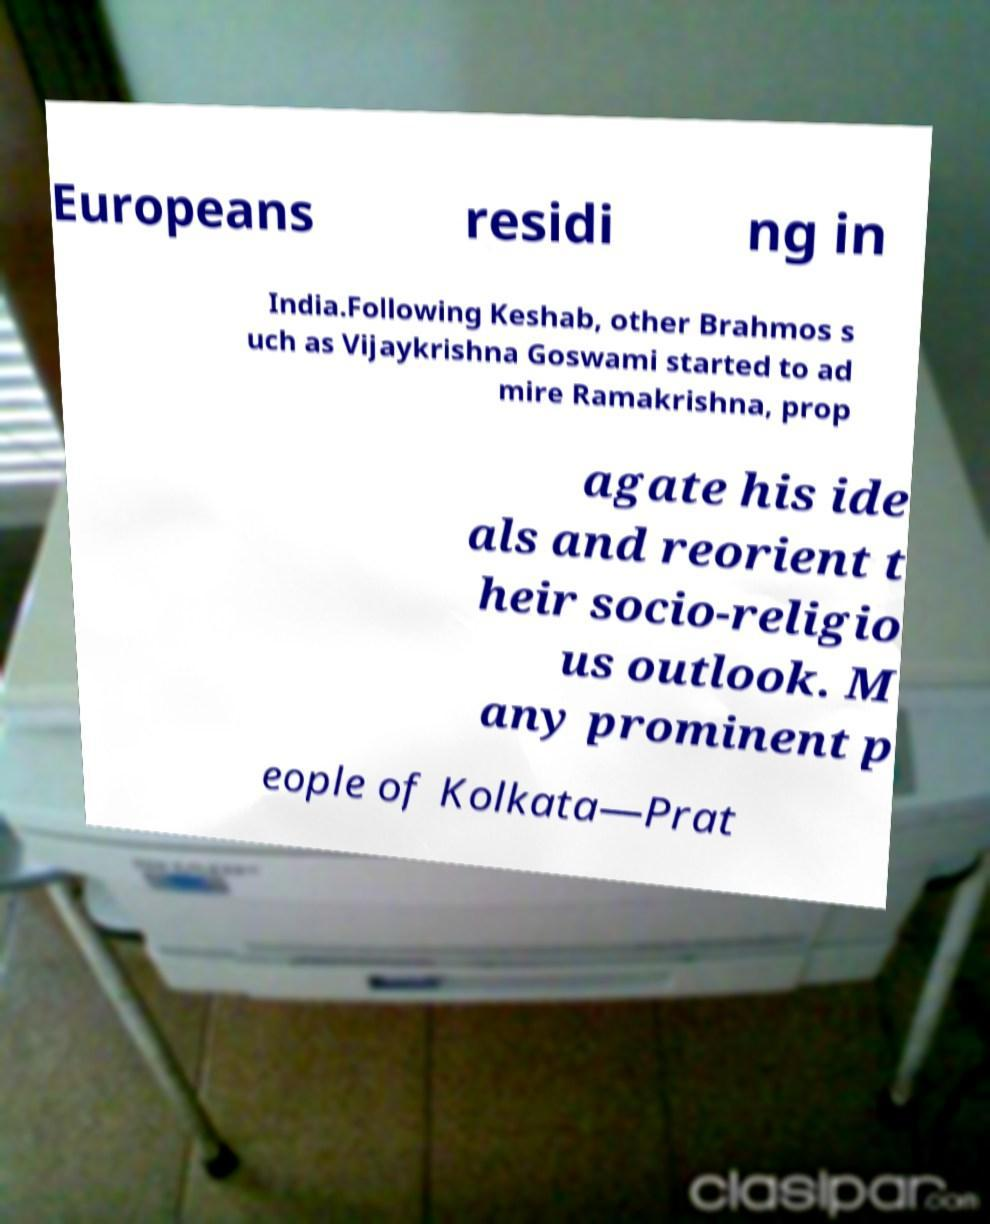I need the written content from this picture converted into text. Can you do that? Europeans residi ng in India.Following Keshab, other Brahmos s uch as Vijaykrishna Goswami started to ad mire Ramakrishna, prop agate his ide als and reorient t heir socio-religio us outlook. M any prominent p eople of Kolkata—Prat 